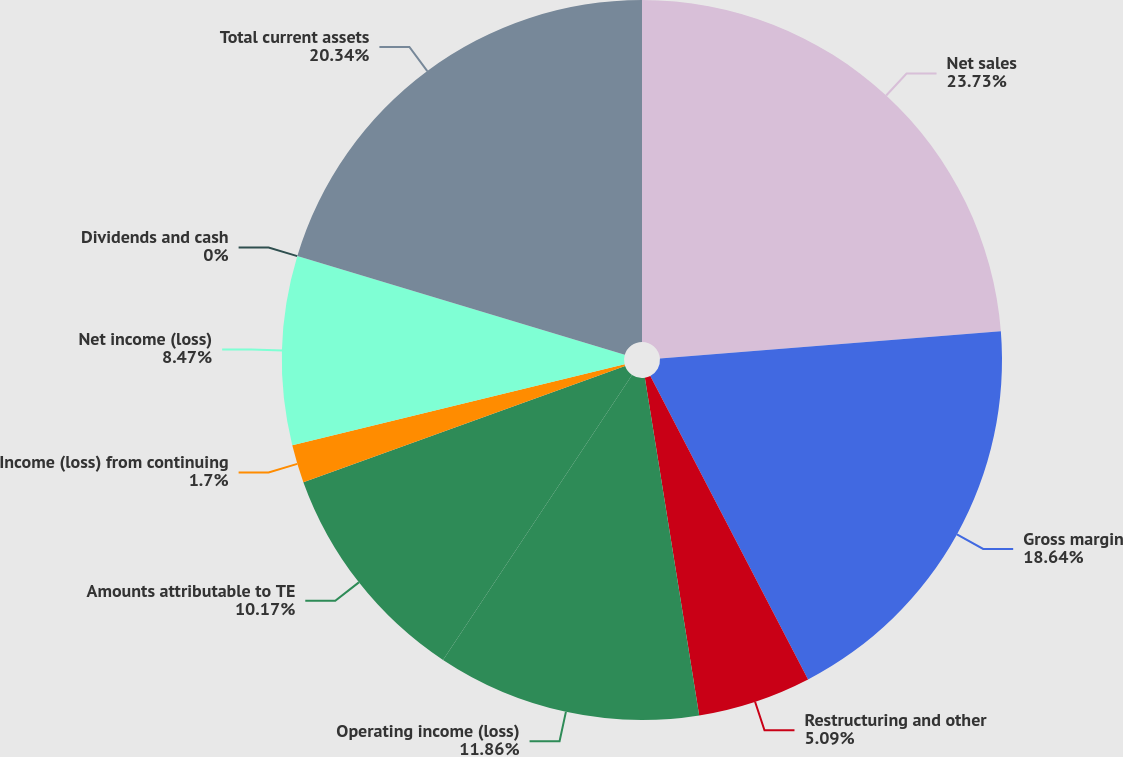<chart> <loc_0><loc_0><loc_500><loc_500><pie_chart><fcel>Net sales<fcel>Gross margin<fcel>Restructuring and other<fcel>Operating income (loss)<fcel>Amounts attributable to TE<fcel>Income (loss) from continuing<fcel>Net income (loss)<fcel>Dividends and cash<fcel>Total current assets<nl><fcel>23.73%<fcel>18.64%<fcel>5.09%<fcel>11.86%<fcel>10.17%<fcel>1.7%<fcel>8.47%<fcel>0.0%<fcel>20.34%<nl></chart> 